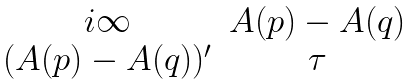Convert formula to latex. <formula><loc_0><loc_0><loc_500><loc_500>\begin{matrix} i \infty & A ( p ) - A ( q ) \\ ( A ( p ) - A ( q ) ) ^ { \prime } & \tau \end{matrix}</formula> 